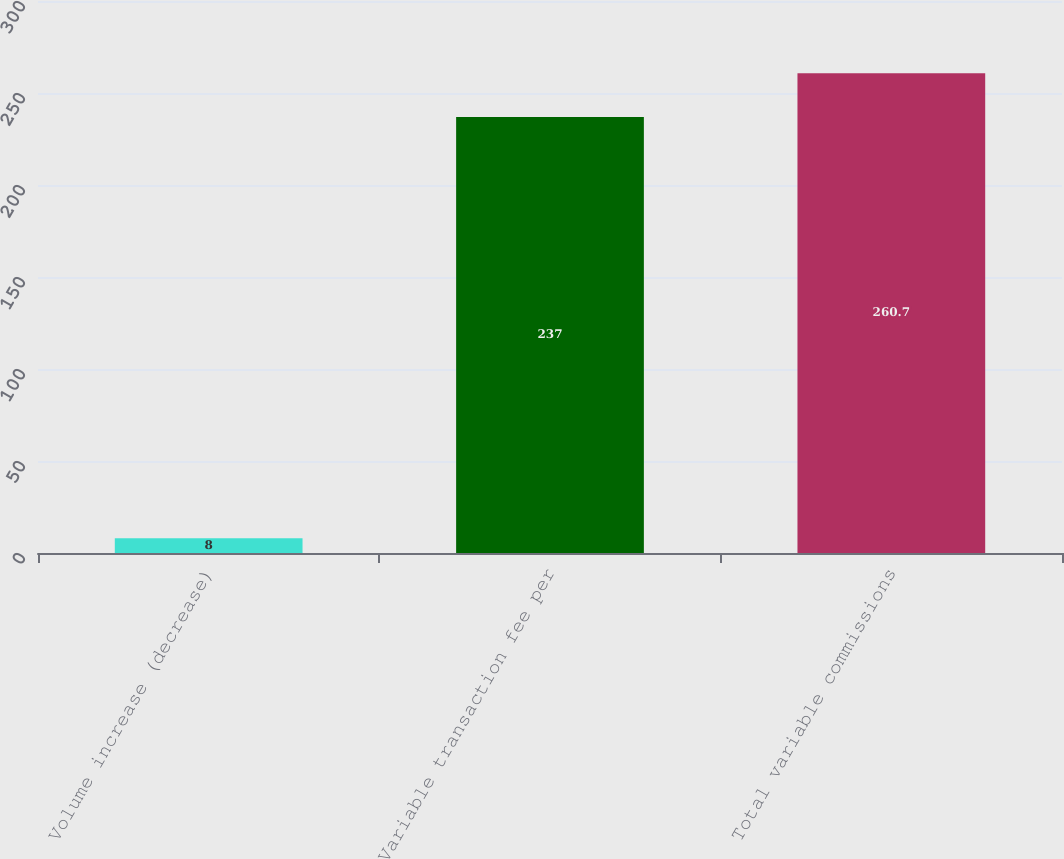Convert chart to OTSL. <chart><loc_0><loc_0><loc_500><loc_500><bar_chart><fcel>Volume increase (decrease)<fcel>Variable transaction fee per<fcel>Total variable commissions<nl><fcel>8<fcel>237<fcel>260.7<nl></chart> 